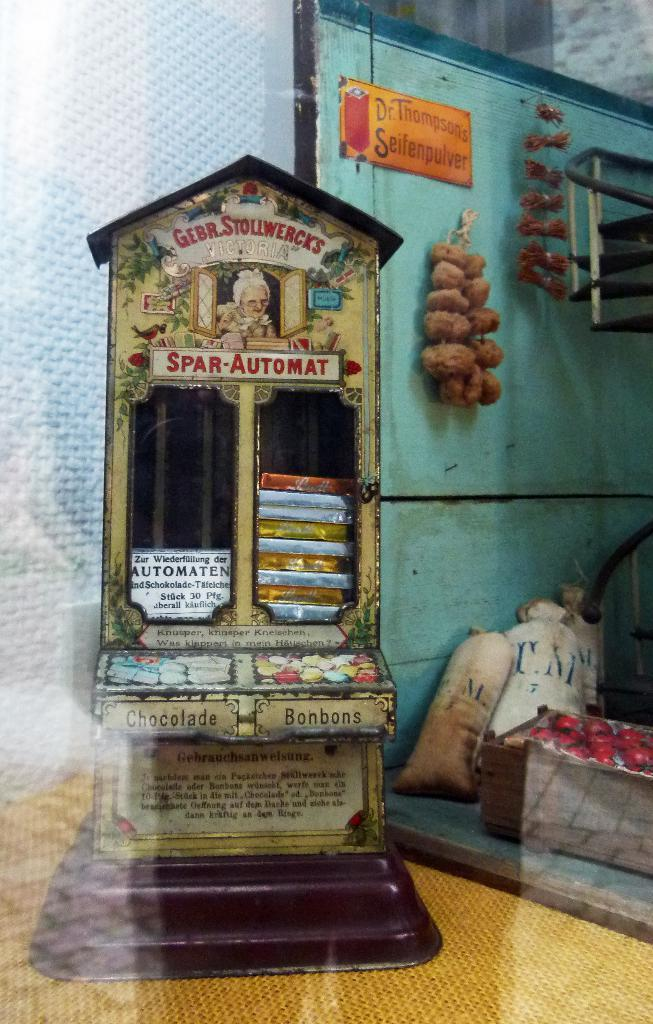What type of furniture is present in the image? There is a cupboard in the image. What can be seen on the wall in the image? Objects are hanged on the wall in the image. What type of containers are visible in the image? There are sacks in the image. What is placed on the ground in the image? There is a box with fruits on the ground in the image. What time of day is depicted in the image, considering the presence of the moon? The image does not show the moon; it only contains a cupboard, objects on the wall, sacks, and a box with fruits on the ground. What type of journey is being taken in the image? There is no journey depicted in the image; it is a still scene with various objects and containers. 